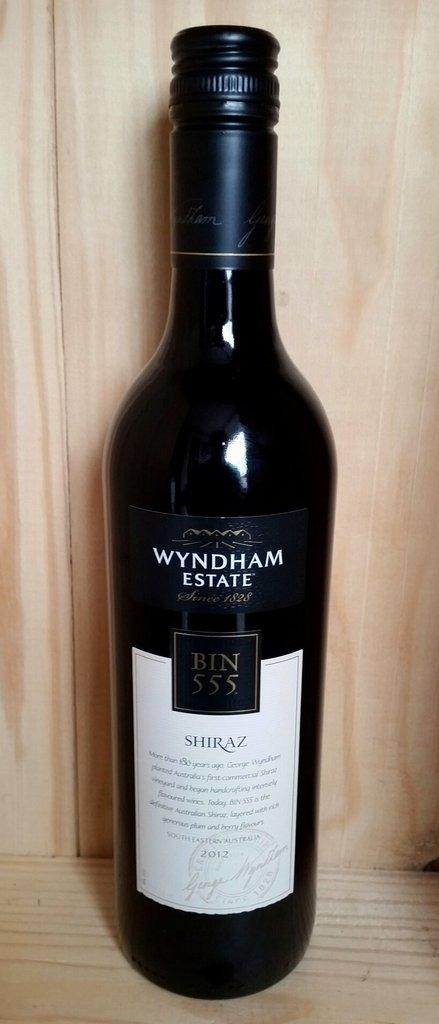<image>
Share a concise interpretation of the image provided. A bottle of WYNDHAM ESTATE wine in a black bottle with white label is sitting on a table. 